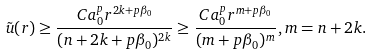<formula> <loc_0><loc_0><loc_500><loc_500>\tilde { u } ( r ) \geq \frac { C a _ { 0 } ^ { p } r ^ { 2 k + p \beta _ { 0 } } } { ( n + 2 k + p \beta _ { 0 } ) ^ { 2 k } } \geq \frac { C a _ { 0 } ^ { p } r ^ { m + p \beta _ { 0 } } } { ( m + p \beta _ { 0 } ) ^ { m } } , m = n + 2 k .</formula> 